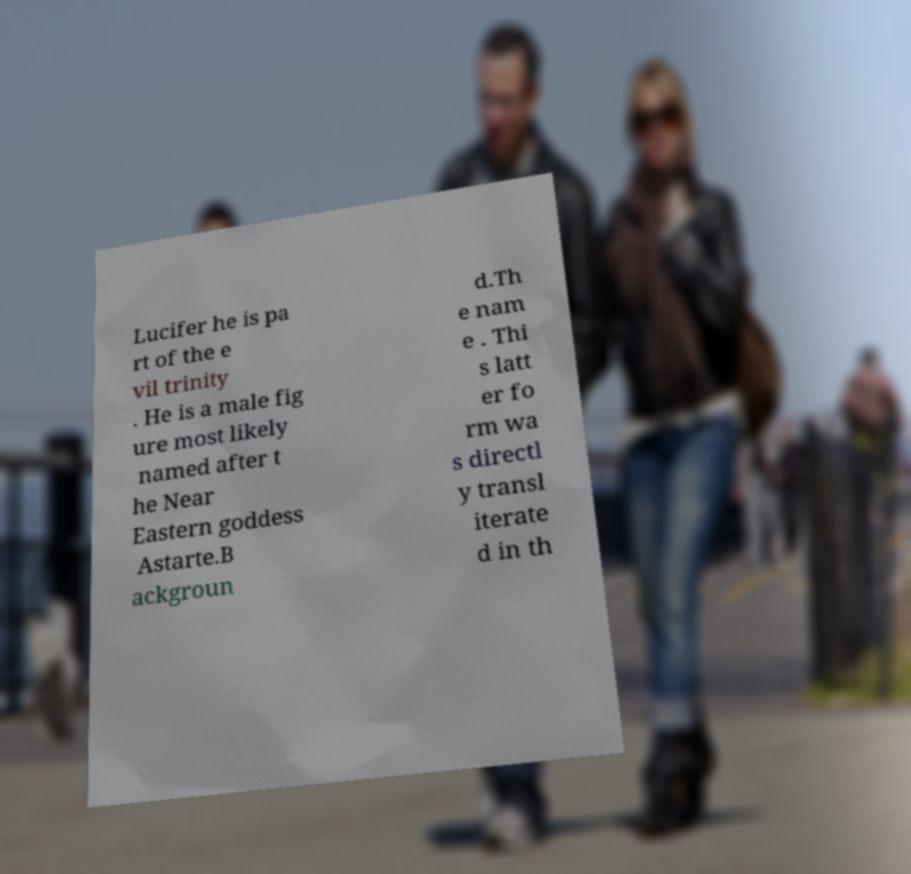I need the written content from this picture converted into text. Can you do that? Lucifer he is pa rt of the e vil trinity . He is a male fig ure most likely named after t he Near Eastern goddess Astarte.B ackgroun d.Th e nam e . Thi s latt er fo rm wa s directl y transl iterate d in th 